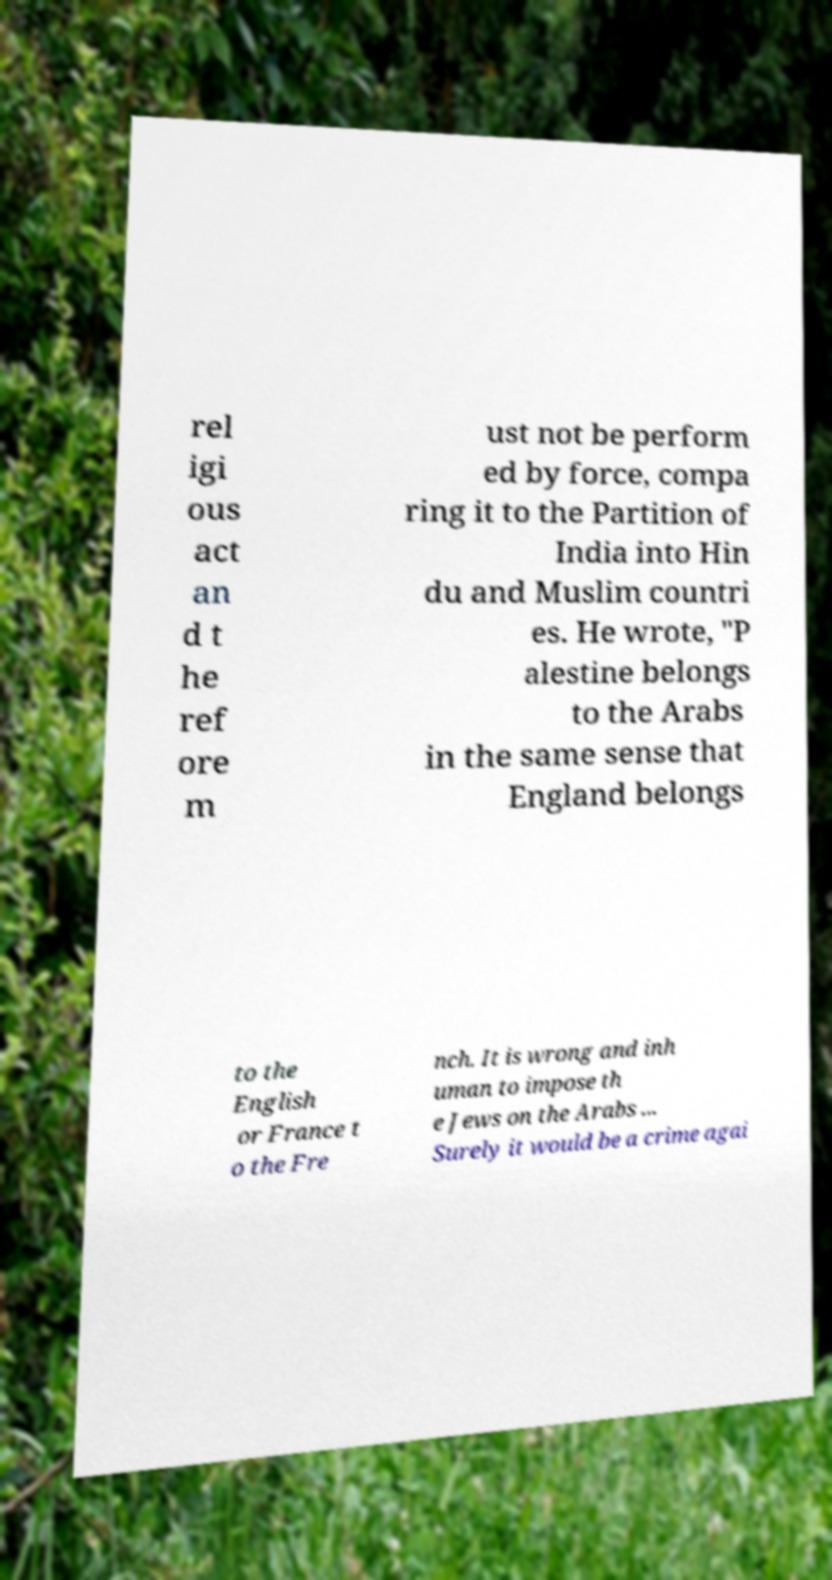Please read and relay the text visible in this image. What does it say? rel igi ous act an d t he ref ore m ust not be perform ed by force, compa ring it to the Partition of India into Hin du and Muslim countri es. He wrote, "P alestine belongs to the Arabs in the same sense that England belongs to the English or France t o the Fre nch. It is wrong and inh uman to impose th e Jews on the Arabs ... Surely it would be a crime agai 